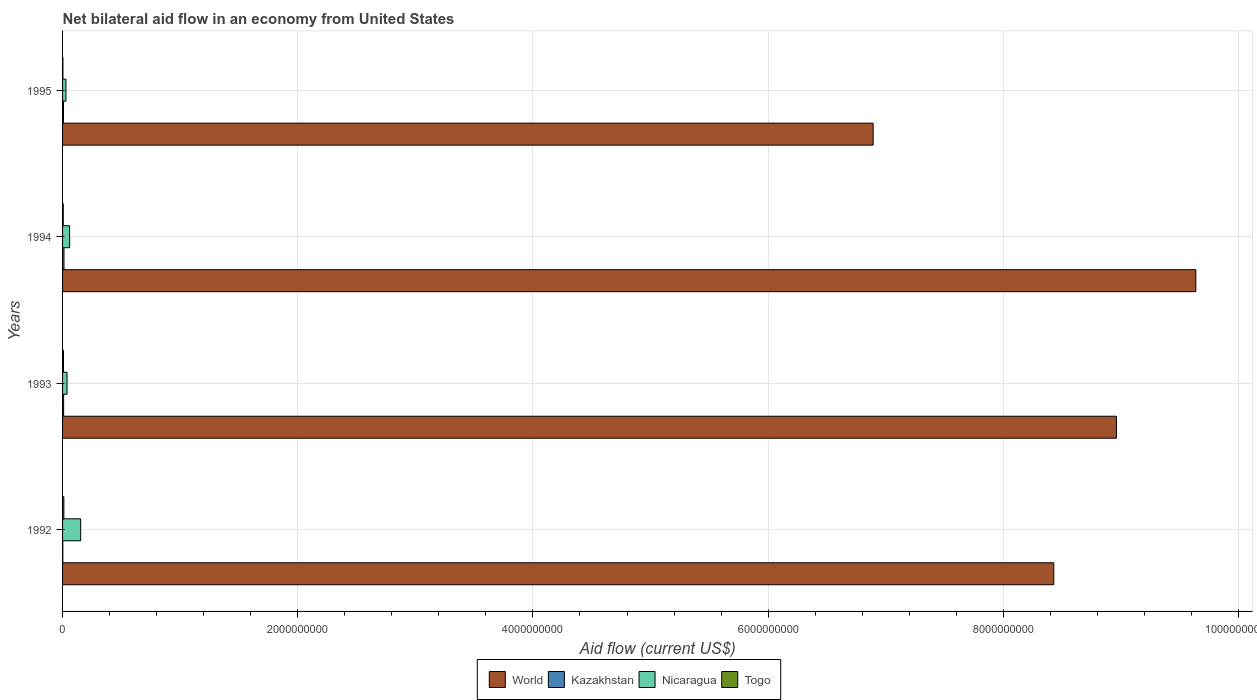How many different coloured bars are there?
Your answer should be compact. 4. Are the number of bars per tick equal to the number of legend labels?
Offer a terse response. Yes. How many bars are there on the 4th tick from the top?
Provide a succinct answer. 4. How many bars are there on the 4th tick from the bottom?
Provide a short and direct response. 4. What is the label of the 3rd group of bars from the top?
Provide a short and direct response. 1993. What is the net bilateral aid flow in Nicaragua in 1994?
Provide a short and direct response. 6.00e+07. Across all years, what is the maximum net bilateral aid flow in World?
Offer a terse response. 9.64e+09. Across all years, what is the minimum net bilateral aid flow in Nicaragua?
Provide a succinct answer. 2.90e+07. In which year was the net bilateral aid flow in Togo maximum?
Offer a terse response. 1992. In which year was the net bilateral aid flow in Togo minimum?
Your answer should be compact. 1995. What is the total net bilateral aid flow in Kazakhstan in the graph?
Offer a very short reply. 3.10e+07. What is the difference between the net bilateral aid flow in Kazakhstan in 1992 and that in 1993?
Your response must be concise. -7.00e+06. What is the difference between the net bilateral aid flow in Kazakhstan in 1994 and the net bilateral aid flow in Togo in 1995?
Your answer should be compact. 9.00e+06. What is the average net bilateral aid flow in Nicaragua per year?
Offer a very short reply. 7.02e+07. In the year 1993, what is the difference between the net bilateral aid flow in Nicaragua and net bilateral aid flow in Togo?
Your response must be concise. 3.00e+07. What is the ratio of the net bilateral aid flow in Togo in 1993 to that in 1994?
Give a very brief answer. 1.33. Is the net bilateral aid flow in Togo in 1992 less than that in 1994?
Your answer should be compact. No. Is the difference between the net bilateral aid flow in Nicaragua in 1993 and 1994 greater than the difference between the net bilateral aid flow in Togo in 1993 and 1994?
Your response must be concise. No. What is the difference between the highest and the second highest net bilateral aid flow in Nicaragua?
Provide a succinct answer. 9.40e+07. What is the difference between the highest and the lowest net bilateral aid flow in Togo?
Your answer should be compact. 8.00e+06. In how many years, is the net bilateral aid flow in World greater than the average net bilateral aid flow in World taken over all years?
Your response must be concise. 2. Is the sum of the net bilateral aid flow in Kazakhstan in 1992 and 1994 greater than the maximum net bilateral aid flow in Togo across all years?
Provide a short and direct response. Yes. What does the 1st bar from the bottom in 1992 represents?
Make the answer very short. World. Is it the case that in every year, the sum of the net bilateral aid flow in Nicaragua and net bilateral aid flow in World is greater than the net bilateral aid flow in Kazakhstan?
Provide a short and direct response. Yes. How many bars are there?
Make the answer very short. 16. Are all the bars in the graph horizontal?
Keep it short and to the point. Yes. What is the difference between two consecutive major ticks on the X-axis?
Provide a succinct answer. 2.00e+09. Are the values on the major ticks of X-axis written in scientific E-notation?
Make the answer very short. No. Does the graph contain grids?
Offer a very short reply. Yes. How many legend labels are there?
Keep it short and to the point. 4. How are the legend labels stacked?
Make the answer very short. Horizontal. What is the title of the graph?
Your response must be concise. Net bilateral aid flow in an economy from United States. What is the label or title of the X-axis?
Your answer should be compact. Aid flow (current US$). What is the Aid flow (current US$) of World in 1992?
Your answer should be very brief. 8.43e+09. What is the Aid flow (current US$) in Nicaragua in 1992?
Offer a very short reply. 1.54e+08. What is the Aid flow (current US$) of Togo in 1992?
Your answer should be very brief. 1.10e+07. What is the Aid flow (current US$) in World in 1993?
Ensure brevity in your answer.  8.96e+09. What is the Aid flow (current US$) of Kazakhstan in 1993?
Offer a terse response. 9.00e+06. What is the Aid flow (current US$) in Nicaragua in 1993?
Give a very brief answer. 3.80e+07. What is the Aid flow (current US$) in Togo in 1993?
Your response must be concise. 8.00e+06. What is the Aid flow (current US$) in World in 1994?
Provide a short and direct response. 9.64e+09. What is the Aid flow (current US$) in Nicaragua in 1994?
Keep it short and to the point. 6.00e+07. What is the Aid flow (current US$) in Togo in 1994?
Offer a very short reply. 6.00e+06. What is the Aid flow (current US$) of World in 1995?
Provide a short and direct response. 6.89e+09. What is the Aid flow (current US$) in Nicaragua in 1995?
Your response must be concise. 2.90e+07. Across all years, what is the maximum Aid flow (current US$) of World?
Keep it short and to the point. 9.64e+09. Across all years, what is the maximum Aid flow (current US$) in Kazakhstan?
Make the answer very short. 1.20e+07. Across all years, what is the maximum Aid flow (current US$) of Nicaragua?
Provide a short and direct response. 1.54e+08. Across all years, what is the maximum Aid flow (current US$) in Togo?
Keep it short and to the point. 1.10e+07. Across all years, what is the minimum Aid flow (current US$) of World?
Give a very brief answer. 6.89e+09. Across all years, what is the minimum Aid flow (current US$) of Kazakhstan?
Your answer should be very brief. 2.00e+06. Across all years, what is the minimum Aid flow (current US$) in Nicaragua?
Your answer should be very brief. 2.90e+07. What is the total Aid flow (current US$) of World in the graph?
Provide a succinct answer. 3.39e+1. What is the total Aid flow (current US$) in Kazakhstan in the graph?
Provide a short and direct response. 3.10e+07. What is the total Aid flow (current US$) in Nicaragua in the graph?
Your answer should be very brief. 2.81e+08. What is the total Aid flow (current US$) of Togo in the graph?
Provide a short and direct response. 2.80e+07. What is the difference between the Aid flow (current US$) in World in 1992 and that in 1993?
Keep it short and to the point. -5.33e+08. What is the difference between the Aid flow (current US$) in Kazakhstan in 1992 and that in 1993?
Give a very brief answer. -7.00e+06. What is the difference between the Aid flow (current US$) in Nicaragua in 1992 and that in 1993?
Your answer should be very brief. 1.16e+08. What is the difference between the Aid flow (current US$) of World in 1992 and that in 1994?
Make the answer very short. -1.21e+09. What is the difference between the Aid flow (current US$) of Kazakhstan in 1992 and that in 1994?
Offer a very short reply. -1.00e+07. What is the difference between the Aid flow (current US$) of Nicaragua in 1992 and that in 1994?
Give a very brief answer. 9.40e+07. What is the difference between the Aid flow (current US$) of Togo in 1992 and that in 1994?
Your response must be concise. 5.00e+06. What is the difference between the Aid flow (current US$) of World in 1992 and that in 1995?
Your answer should be very brief. 1.54e+09. What is the difference between the Aid flow (current US$) in Kazakhstan in 1992 and that in 1995?
Your answer should be compact. -6.00e+06. What is the difference between the Aid flow (current US$) of Nicaragua in 1992 and that in 1995?
Make the answer very short. 1.25e+08. What is the difference between the Aid flow (current US$) of World in 1993 and that in 1994?
Provide a short and direct response. -6.75e+08. What is the difference between the Aid flow (current US$) of Kazakhstan in 1993 and that in 1994?
Give a very brief answer. -3.00e+06. What is the difference between the Aid flow (current US$) in Nicaragua in 1993 and that in 1994?
Your answer should be very brief. -2.20e+07. What is the difference between the Aid flow (current US$) in Togo in 1993 and that in 1994?
Your response must be concise. 2.00e+06. What is the difference between the Aid flow (current US$) of World in 1993 and that in 1995?
Your answer should be very brief. 2.07e+09. What is the difference between the Aid flow (current US$) of Nicaragua in 1993 and that in 1995?
Your response must be concise. 9.00e+06. What is the difference between the Aid flow (current US$) in Togo in 1993 and that in 1995?
Your answer should be compact. 5.00e+06. What is the difference between the Aid flow (current US$) of World in 1994 and that in 1995?
Provide a succinct answer. 2.74e+09. What is the difference between the Aid flow (current US$) in Kazakhstan in 1994 and that in 1995?
Offer a very short reply. 4.00e+06. What is the difference between the Aid flow (current US$) in Nicaragua in 1994 and that in 1995?
Your answer should be very brief. 3.10e+07. What is the difference between the Aid flow (current US$) in World in 1992 and the Aid flow (current US$) in Kazakhstan in 1993?
Make the answer very short. 8.42e+09. What is the difference between the Aid flow (current US$) in World in 1992 and the Aid flow (current US$) in Nicaragua in 1993?
Your answer should be very brief. 8.39e+09. What is the difference between the Aid flow (current US$) of World in 1992 and the Aid flow (current US$) of Togo in 1993?
Your answer should be compact. 8.42e+09. What is the difference between the Aid flow (current US$) in Kazakhstan in 1992 and the Aid flow (current US$) in Nicaragua in 1993?
Ensure brevity in your answer.  -3.60e+07. What is the difference between the Aid flow (current US$) of Kazakhstan in 1992 and the Aid flow (current US$) of Togo in 1993?
Keep it short and to the point. -6.00e+06. What is the difference between the Aid flow (current US$) in Nicaragua in 1992 and the Aid flow (current US$) in Togo in 1993?
Ensure brevity in your answer.  1.46e+08. What is the difference between the Aid flow (current US$) in World in 1992 and the Aid flow (current US$) in Kazakhstan in 1994?
Your response must be concise. 8.42e+09. What is the difference between the Aid flow (current US$) of World in 1992 and the Aid flow (current US$) of Nicaragua in 1994?
Keep it short and to the point. 8.37e+09. What is the difference between the Aid flow (current US$) of World in 1992 and the Aid flow (current US$) of Togo in 1994?
Provide a succinct answer. 8.42e+09. What is the difference between the Aid flow (current US$) in Kazakhstan in 1992 and the Aid flow (current US$) in Nicaragua in 1994?
Your answer should be very brief. -5.80e+07. What is the difference between the Aid flow (current US$) of Kazakhstan in 1992 and the Aid flow (current US$) of Togo in 1994?
Make the answer very short. -4.00e+06. What is the difference between the Aid flow (current US$) of Nicaragua in 1992 and the Aid flow (current US$) of Togo in 1994?
Keep it short and to the point. 1.48e+08. What is the difference between the Aid flow (current US$) in World in 1992 and the Aid flow (current US$) in Kazakhstan in 1995?
Make the answer very short. 8.42e+09. What is the difference between the Aid flow (current US$) of World in 1992 and the Aid flow (current US$) of Nicaragua in 1995?
Provide a short and direct response. 8.40e+09. What is the difference between the Aid flow (current US$) in World in 1992 and the Aid flow (current US$) in Togo in 1995?
Your answer should be very brief. 8.43e+09. What is the difference between the Aid flow (current US$) in Kazakhstan in 1992 and the Aid flow (current US$) in Nicaragua in 1995?
Your answer should be compact. -2.70e+07. What is the difference between the Aid flow (current US$) in Nicaragua in 1992 and the Aid flow (current US$) in Togo in 1995?
Keep it short and to the point. 1.51e+08. What is the difference between the Aid flow (current US$) in World in 1993 and the Aid flow (current US$) in Kazakhstan in 1994?
Your answer should be compact. 8.95e+09. What is the difference between the Aid flow (current US$) in World in 1993 and the Aid flow (current US$) in Nicaragua in 1994?
Ensure brevity in your answer.  8.90e+09. What is the difference between the Aid flow (current US$) of World in 1993 and the Aid flow (current US$) of Togo in 1994?
Ensure brevity in your answer.  8.96e+09. What is the difference between the Aid flow (current US$) of Kazakhstan in 1993 and the Aid flow (current US$) of Nicaragua in 1994?
Provide a short and direct response. -5.10e+07. What is the difference between the Aid flow (current US$) in Nicaragua in 1993 and the Aid flow (current US$) in Togo in 1994?
Offer a very short reply. 3.20e+07. What is the difference between the Aid flow (current US$) in World in 1993 and the Aid flow (current US$) in Kazakhstan in 1995?
Make the answer very short. 8.95e+09. What is the difference between the Aid flow (current US$) of World in 1993 and the Aid flow (current US$) of Nicaragua in 1995?
Keep it short and to the point. 8.93e+09. What is the difference between the Aid flow (current US$) in World in 1993 and the Aid flow (current US$) in Togo in 1995?
Offer a terse response. 8.96e+09. What is the difference between the Aid flow (current US$) of Kazakhstan in 1993 and the Aid flow (current US$) of Nicaragua in 1995?
Provide a short and direct response. -2.00e+07. What is the difference between the Aid flow (current US$) in Nicaragua in 1993 and the Aid flow (current US$) in Togo in 1995?
Provide a succinct answer. 3.50e+07. What is the difference between the Aid flow (current US$) in World in 1994 and the Aid flow (current US$) in Kazakhstan in 1995?
Offer a very short reply. 9.63e+09. What is the difference between the Aid flow (current US$) in World in 1994 and the Aid flow (current US$) in Nicaragua in 1995?
Your answer should be compact. 9.61e+09. What is the difference between the Aid flow (current US$) in World in 1994 and the Aid flow (current US$) in Togo in 1995?
Your answer should be very brief. 9.63e+09. What is the difference between the Aid flow (current US$) in Kazakhstan in 1994 and the Aid flow (current US$) in Nicaragua in 1995?
Offer a terse response. -1.70e+07. What is the difference between the Aid flow (current US$) of Kazakhstan in 1994 and the Aid flow (current US$) of Togo in 1995?
Your response must be concise. 9.00e+06. What is the difference between the Aid flow (current US$) in Nicaragua in 1994 and the Aid flow (current US$) in Togo in 1995?
Provide a succinct answer. 5.70e+07. What is the average Aid flow (current US$) of World per year?
Offer a terse response. 8.48e+09. What is the average Aid flow (current US$) in Kazakhstan per year?
Your response must be concise. 7.75e+06. What is the average Aid flow (current US$) of Nicaragua per year?
Keep it short and to the point. 7.02e+07. What is the average Aid flow (current US$) in Togo per year?
Make the answer very short. 7.00e+06. In the year 1992, what is the difference between the Aid flow (current US$) of World and Aid flow (current US$) of Kazakhstan?
Provide a succinct answer. 8.43e+09. In the year 1992, what is the difference between the Aid flow (current US$) of World and Aid flow (current US$) of Nicaragua?
Offer a terse response. 8.28e+09. In the year 1992, what is the difference between the Aid flow (current US$) in World and Aid flow (current US$) in Togo?
Give a very brief answer. 8.42e+09. In the year 1992, what is the difference between the Aid flow (current US$) in Kazakhstan and Aid flow (current US$) in Nicaragua?
Keep it short and to the point. -1.52e+08. In the year 1992, what is the difference between the Aid flow (current US$) in Kazakhstan and Aid flow (current US$) in Togo?
Offer a very short reply. -9.00e+06. In the year 1992, what is the difference between the Aid flow (current US$) in Nicaragua and Aid flow (current US$) in Togo?
Your answer should be compact. 1.43e+08. In the year 1993, what is the difference between the Aid flow (current US$) in World and Aid flow (current US$) in Kazakhstan?
Provide a succinct answer. 8.95e+09. In the year 1993, what is the difference between the Aid flow (current US$) of World and Aid flow (current US$) of Nicaragua?
Offer a terse response. 8.92e+09. In the year 1993, what is the difference between the Aid flow (current US$) of World and Aid flow (current US$) of Togo?
Your answer should be compact. 8.95e+09. In the year 1993, what is the difference between the Aid flow (current US$) in Kazakhstan and Aid flow (current US$) in Nicaragua?
Provide a short and direct response. -2.90e+07. In the year 1993, what is the difference between the Aid flow (current US$) in Nicaragua and Aid flow (current US$) in Togo?
Your response must be concise. 3.00e+07. In the year 1994, what is the difference between the Aid flow (current US$) of World and Aid flow (current US$) of Kazakhstan?
Give a very brief answer. 9.62e+09. In the year 1994, what is the difference between the Aid flow (current US$) in World and Aid flow (current US$) in Nicaragua?
Make the answer very short. 9.58e+09. In the year 1994, what is the difference between the Aid flow (current US$) of World and Aid flow (current US$) of Togo?
Make the answer very short. 9.63e+09. In the year 1994, what is the difference between the Aid flow (current US$) of Kazakhstan and Aid flow (current US$) of Nicaragua?
Offer a terse response. -4.80e+07. In the year 1994, what is the difference between the Aid flow (current US$) of Kazakhstan and Aid flow (current US$) of Togo?
Your answer should be compact. 6.00e+06. In the year 1994, what is the difference between the Aid flow (current US$) in Nicaragua and Aid flow (current US$) in Togo?
Offer a terse response. 5.40e+07. In the year 1995, what is the difference between the Aid flow (current US$) in World and Aid flow (current US$) in Kazakhstan?
Make the answer very short. 6.88e+09. In the year 1995, what is the difference between the Aid flow (current US$) in World and Aid flow (current US$) in Nicaragua?
Your response must be concise. 6.86e+09. In the year 1995, what is the difference between the Aid flow (current US$) of World and Aid flow (current US$) of Togo?
Your answer should be compact. 6.89e+09. In the year 1995, what is the difference between the Aid flow (current US$) of Kazakhstan and Aid flow (current US$) of Nicaragua?
Keep it short and to the point. -2.10e+07. In the year 1995, what is the difference between the Aid flow (current US$) of Kazakhstan and Aid flow (current US$) of Togo?
Your answer should be compact. 5.00e+06. In the year 1995, what is the difference between the Aid flow (current US$) in Nicaragua and Aid flow (current US$) in Togo?
Make the answer very short. 2.60e+07. What is the ratio of the Aid flow (current US$) in World in 1992 to that in 1993?
Ensure brevity in your answer.  0.94. What is the ratio of the Aid flow (current US$) of Kazakhstan in 1992 to that in 1993?
Provide a succinct answer. 0.22. What is the ratio of the Aid flow (current US$) in Nicaragua in 1992 to that in 1993?
Your response must be concise. 4.05. What is the ratio of the Aid flow (current US$) in Togo in 1992 to that in 1993?
Offer a very short reply. 1.38. What is the ratio of the Aid flow (current US$) in World in 1992 to that in 1994?
Keep it short and to the point. 0.87. What is the ratio of the Aid flow (current US$) in Nicaragua in 1992 to that in 1994?
Make the answer very short. 2.57. What is the ratio of the Aid flow (current US$) in Togo in 1992 to that in 1994?
Provide a short and direct response. 1.83. What is the ratio of the Aid flow (current US$) of World in 1992 to that in 1995?
Ensure brevity in your answer.  1.22. What is the ratio of the Aid flow (current US$) of Nicaragua in 1992 to that in 1995?
Offer a very short reply. 5.31. What is the ratio of the Aid flow (current US$) in Togo in 1992 to that in 1995?
Provide a short and direct response. 3.67. What is the ratio of the Aid flow (current US$) in Nicaragua in 1993 to that in 1994?
Offer a very short reply. 0.63. What is the ratio of the Aid flow (current US$) in Togo in 1993 to that in 1994?
Your answer should be very brief. 1.33. What is the ratio of the Aid flow (current US$) in World in 1993 to that in 1995?
Ensure brevity in your answer.  1.3. What is the ratio of the Aid flow (current US$) of Nicaragua in 1993 to that in 1995?
Provide a short and direct response. 1.31. What is the ratio of the Aid flow (current US$) in Togo in 1993 to that in 1995?
Ensure brevity in your answer.  2.67. What is the ratio of the Aid flow (current US$) of World in 1994 to that in 1995?
Make the answer very short. 1.4. What is the ratio of the Aid flow (current US$) in Nicaragua in 1994 to that in 1995?
Your answer should be very brief. 2.07. What is the ratio of the Aid flow (current US$) in Togo in 1994 to that in 1995?
Offer a very short reply. 2. What is the difference between the highest and the second highest Aid flow (current US$) of World?
Offer a terse response. 6.75e+08. What is the difference between the highest and the second highest Aid flow (current US$) of Kazakhstan?
Provide a short and direct response. 3.00e+06. What is the difference between the highest and the second highest Aid flow (current US$) in Nicaragua?
Ensure brevity in your answer.  9.40e+07. What is the difference between the highest and the lowest Aid flow (current US$) in World?
Keep it short and to the point. 2.74e+09. What is the difference between the highest and the lowest Aid flow (current US$) of Nicaragua?
Provide a succinct answer. 1.25e+08. 